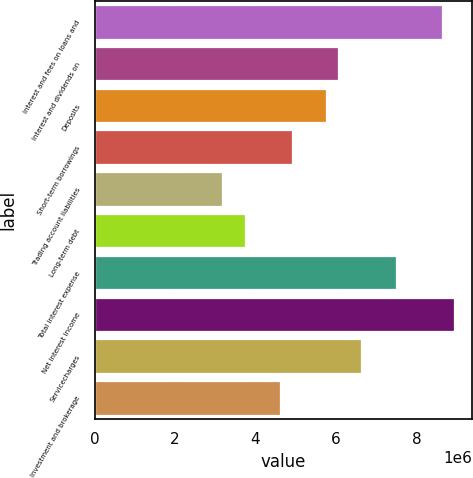Convert chart to OTSL. <chart><loc_0><loc_0><loc_500><loc_500><bar_chart><fcel>Interest and fees on loans and<fcel>Interest and dividends on<fcel>Deposits<fcel>Short-term borrowings<fcel>Trading account liabilities<fcel>Long-term debt<fcel>Total interest expense<fcel>Net interest income<fcel>Servicecharges<fcel>Investment and brokerage<nl><fcel>8.64092e+06<fcel>6.04864e+06<fcel>5.76061e+06<fcel>4.89652e+06<fcel>3.16834e+06<fcel>3.7444e+06<fcel>7.48879e+06<fcel>8.92895e+06<fcel>6.6247e+06<fcel>4.60849e+06<nl></chart> 